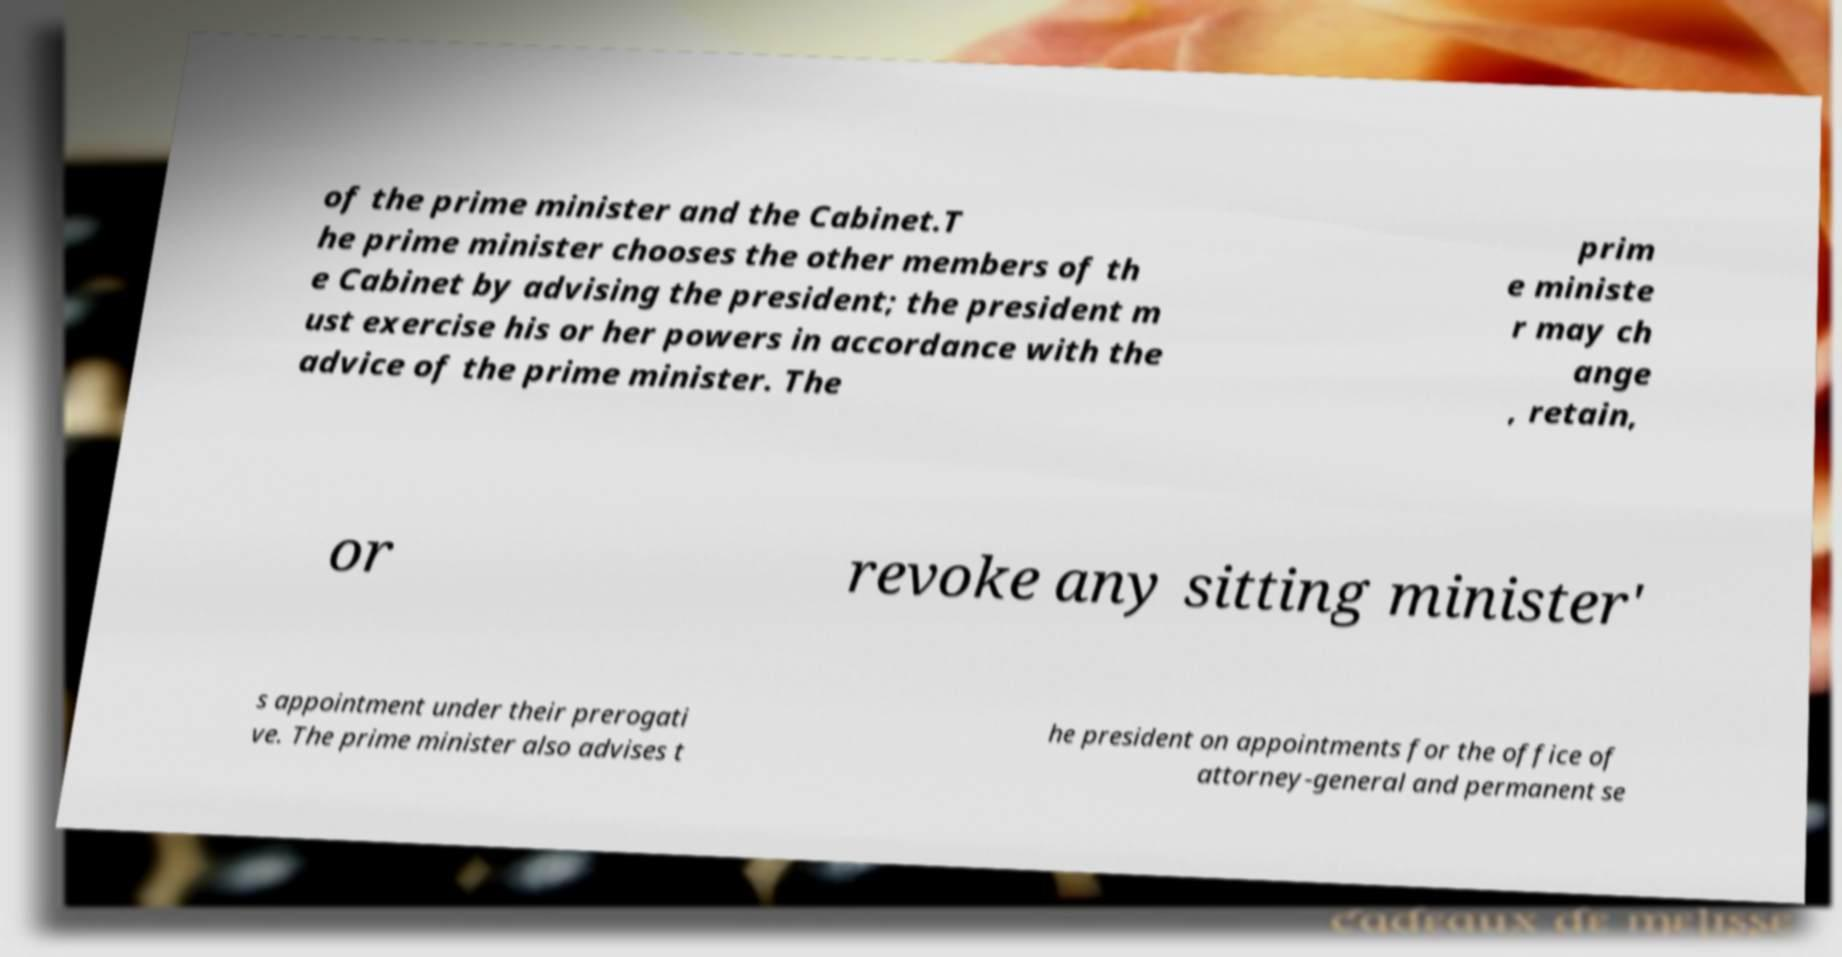For documentation purposes, I need the text within this image transcribed. Could you provide that? of the prime minister and the Cabinet.T he prime minister chooses the other members of th e Cabinet by advising the president; the president m ust exercise his or her powers in accordance with the advice of the prime minister. The prim e ministe r may ch ange , retain, or revoke any sitting minister' s appointment under their prerogati ve. The prime minister also advises t he president on appointments for the office of attorney-general and permanent se 